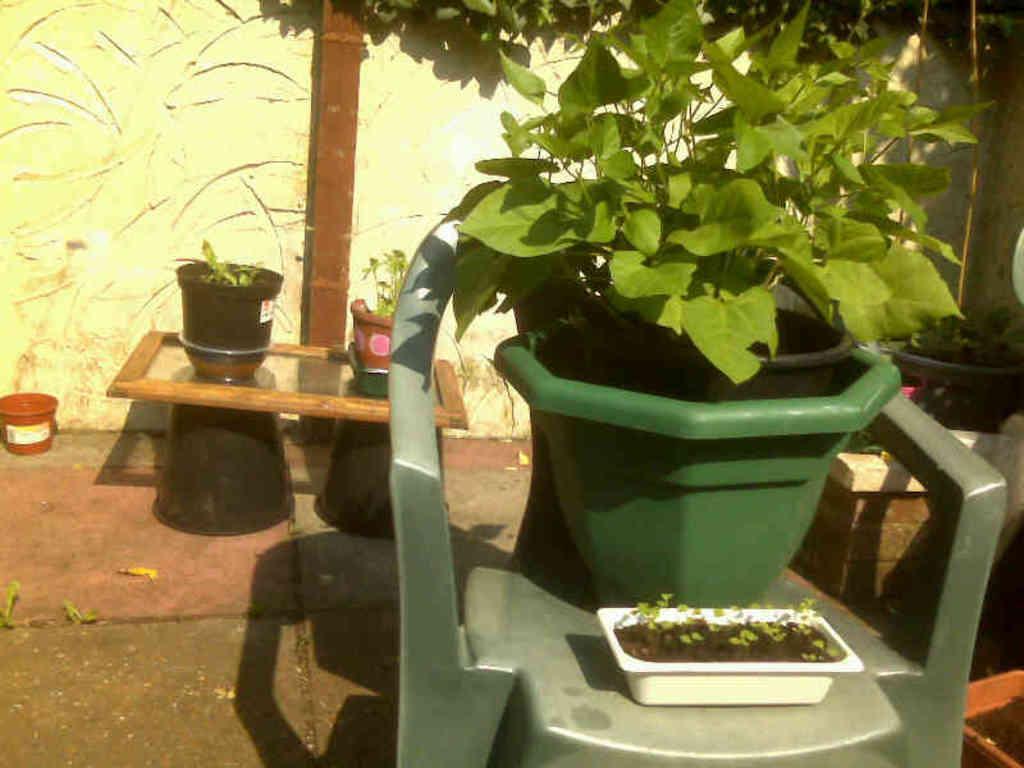Could you give a brief overview of what you see in this image? In this image, there is a chair on which flower pot is kept. In the background, a wall of yellow and white in color. This image is taken in a lawn area during day time. 